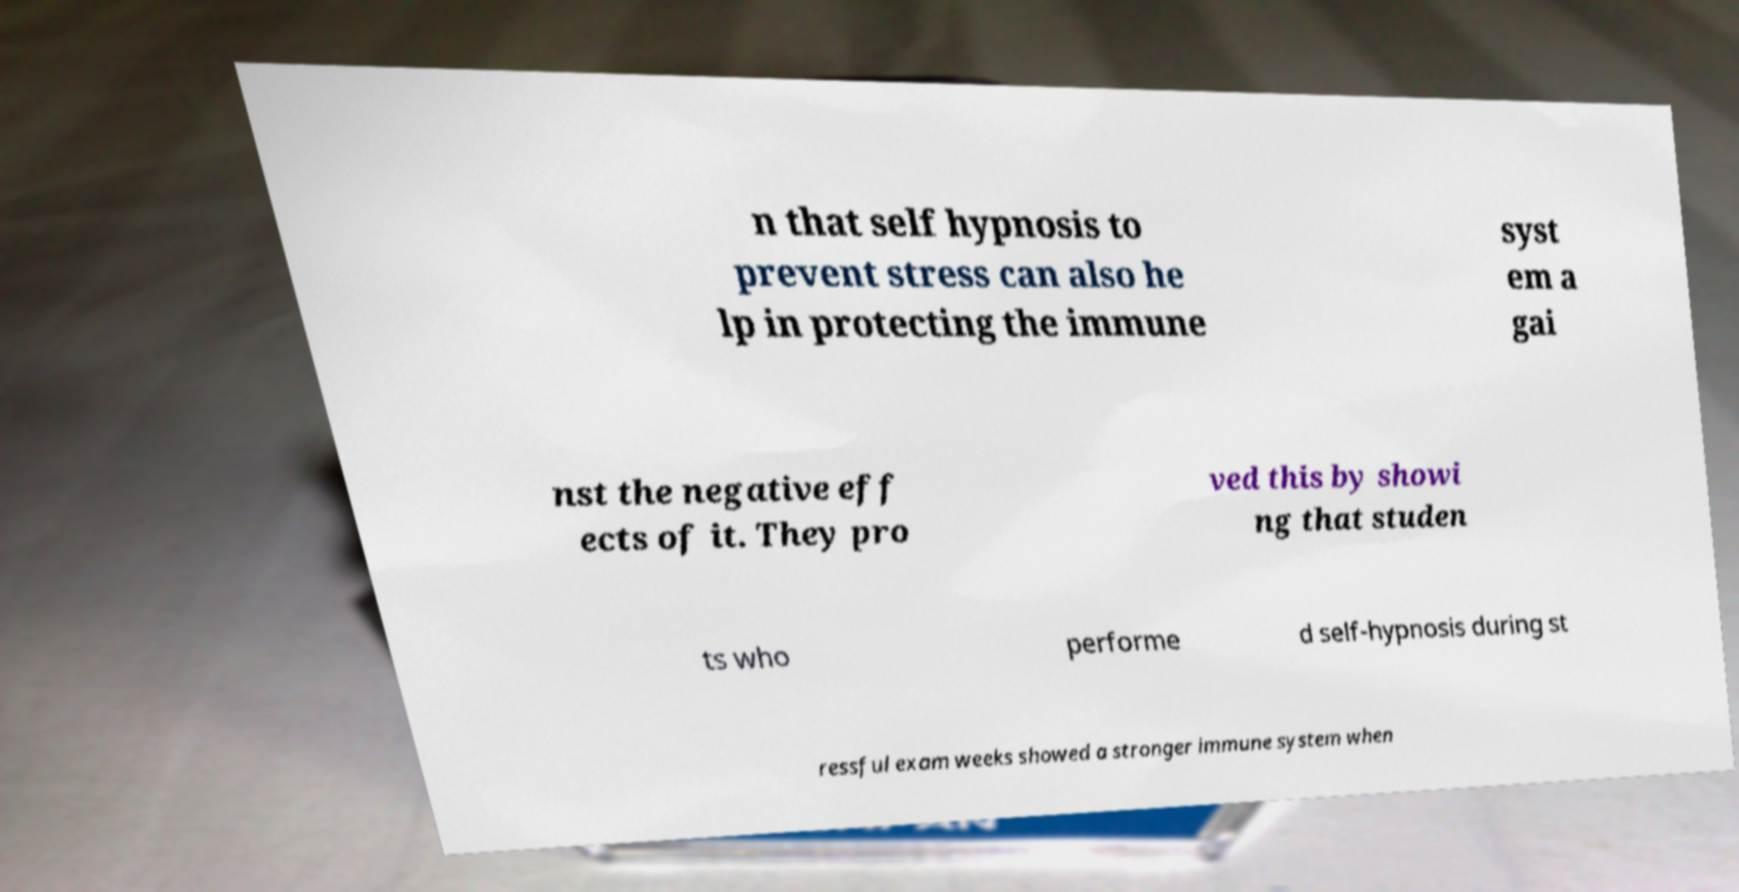Please identify and transcribe the text found in this image. n that self hypnosis to prevent stress can also he lp in protecting the immune syst em a gai nst the negative eff ects of it. They pro ved this by showi ng that studen ts who performe d self-hypnosis during st ressful exam weeks showed a stronger immune system when 